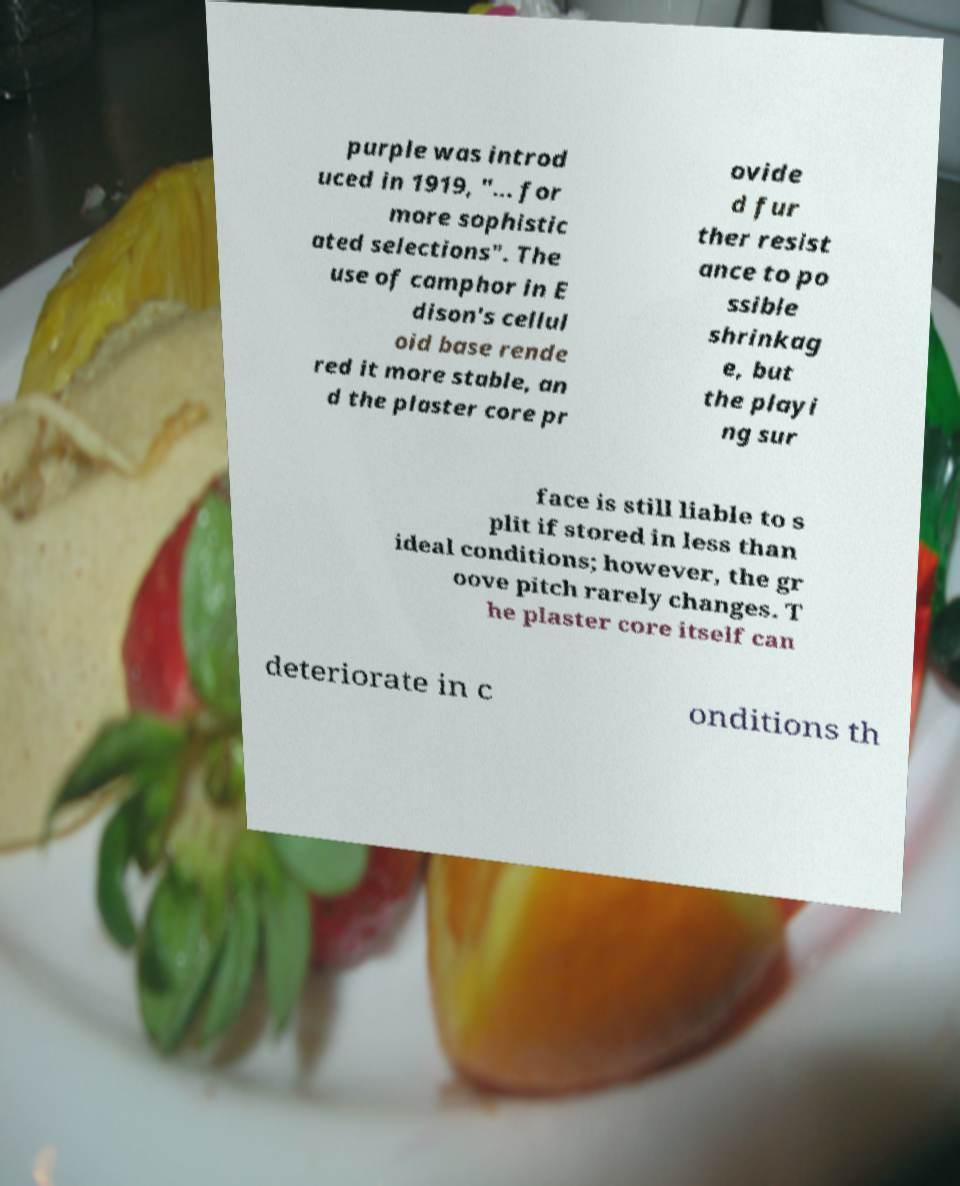Could you assist in decoding the text presented in this image and type it out clearly? purple was introd uced in 1919, "... for more sophistic ated selections". The use of camphor in E dison's cellul oid base rende red it more stable, an d the plaster core pr ovide d fur ther resist ance to po ssible shrinkag e, but the playi ng sur face is still liable to s plit if stored in less than ideal conditions; however, the gr oove pitch rarely changes. T he plaster core itself can deteriorate in c onditions th 